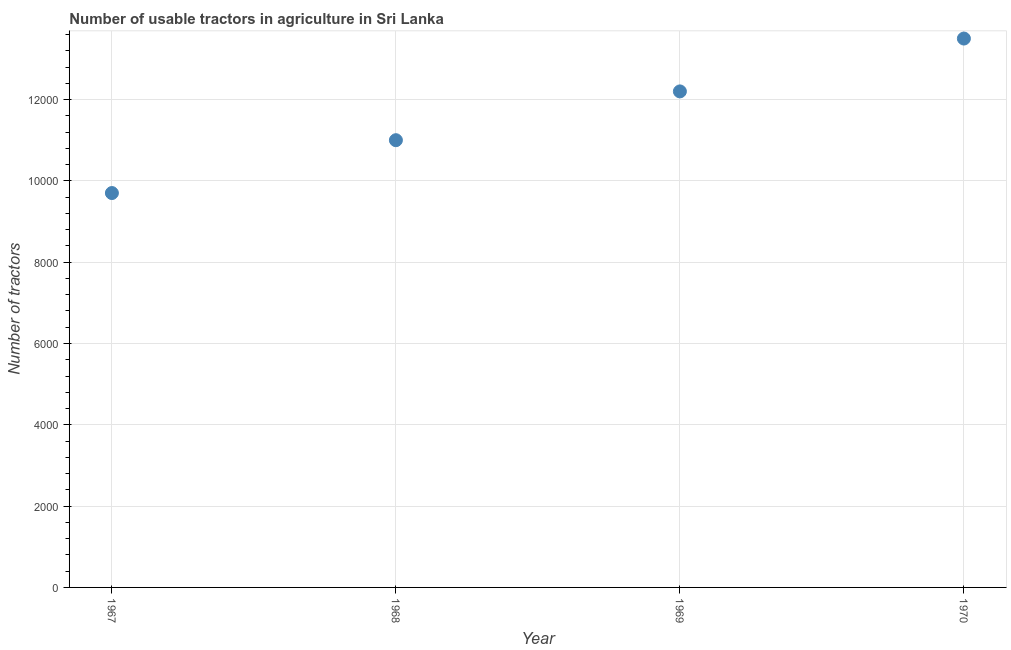What is the number of tractors in 1968?
Your response must be concise. 1.10e+04. Across all years, what is the maximum number of tractors?
Provide a short and direct response. 1.35e+04. Across all years, what is the minimum number of tractors?
Offer a terse response. 9700. In which year was the number of tractors maximum?
Your response must be concise. 1970. In which year was the number of tractors minimum?
Ensure brevity in your answer.  1967. What is the sum of the number of tractors?
Provide a succinct answer. 4.64e+04. What is the difference between the number of tractors in 1968 and 1970?
Give a very brief answer. -2500. What is the average number of tractors per year?
Your response must be concise. 1.16e+04. What is the median number of tractors?
Provide a short and direct response. 1.16e+04. In how many years, is the number of tractors greater than 800 ?
Make the answer very short. 4. Do a majority of the years between 1967 and 1968 (inclusive) have number of tractors greater than 10800 ?
Provide a succinct answer. No. What is the ratio of the number of tractors in 1969 to that in 1970?
Keep it short and to the point. 0.9. Is the number of tractors in 1969 less than that in 1970?
Provide a short and direct response. Yes. Is the difference between the number of tractors in 1967 and 1969 greater than the difference between any two years?
Keep it short and to the point. No. What is the difference between the highest and the second highest number of tractors?
Ensure brevity in your answer.  1300. What is the difference between the highest and the lowest number of tractors?
Give a very brief answer. 3800. In how many years, is the number of tractors greater than the average number of tractors taken over all years?
Offer a very short reply. 2. Does the number of tractors monotonically increase over the years?
Your answer should be compact. Yes. How many dotlines are there?
Provide a succinct answer. 1. How many years are there in the graph?
Make the answer very short. 4. What is the difference between two consecutive major ticks on the Y-axis?
Offer a terse response. 2000. Are the values on the major ticks of Y-axis written in scientific E-notation?
Keep it short and to the point. No. Does the graph contain any zero values?
Make the answer very short. No. What is the title of the graph?
Provide a succinct answer. Number of usable tractors in agriculture in Sri Lanka. What is the label or title of the X-axis?
Ensure brevity in your answer.  Year. What is the label or title of the Y-axis?
Keep it short and to the point. Number of tractors. What is the Number of tractors in 1967?
Keep it short and to the point. 9700. What is the Number of tractors in 1968?
Your answer should be compact. 1.10e+04. What is the Number of tractors in 1969?
Provide a succinct answer. 1.22e+04. What is the Number of tractors in 1970?
Offer a terse response. 1.35e+04. What is the difference between the Number of tractors in 1967 and 1968?
Provide a short and direct response. -1300. What is the difference between the Number of tractors in 1967 and 1969?
Your answer should be compact. -2500. What is the difference between the Number of tractors in 1967 and 1970?
Offer a very short reply. -3800. What is the difference between the Number of tractors in 1968 and 1969?
Ensure brevity in your answer.  -1200. What is the difference between the Number of tractors in 1968 and 1970?
Make the answer very short. -2500. What is the difference between the Number of tractors in 1969 and 1970?
Provide a succinct answer. -1300. What is the ratio of the Number of tractors in 1967 to that in 1968?
Provide a succinct answer. 0.88. What is the ratio of the Number of tractors in 1967 to that in 1969?
Make the answer very short. 0.8. What is the ratio of the Number of tractors in 1967 to that in 1970?
Your response must be concise. 0.72. What is the ratio of the Number of tractors in 1968 to that in 1969?
Make the answer very short. 0.9. What is the ratio of the Number of tractors in 1968 to that in 1970?
Ensure brevity in your answer.  0.81. What is the ratio of the Number of tractors in 1969 to that in 1970?
Ensure brevity in your answer.  0.9. 